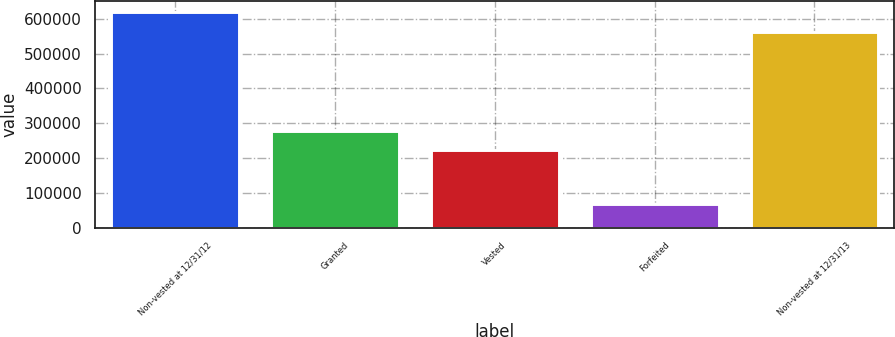<chart> <loc_0><loc_0><loc_500><loc_500><bar_chart><fcel>Non-vested at 12/31/12<fcel>Granted<fcel>Vested<fcel>Forfeited<fcel>Non-vested at 12/31/13<nl><fcel>618910<fcel>276801<fcel>221695<fcel>67851<fcel>560799<nl></chart> 